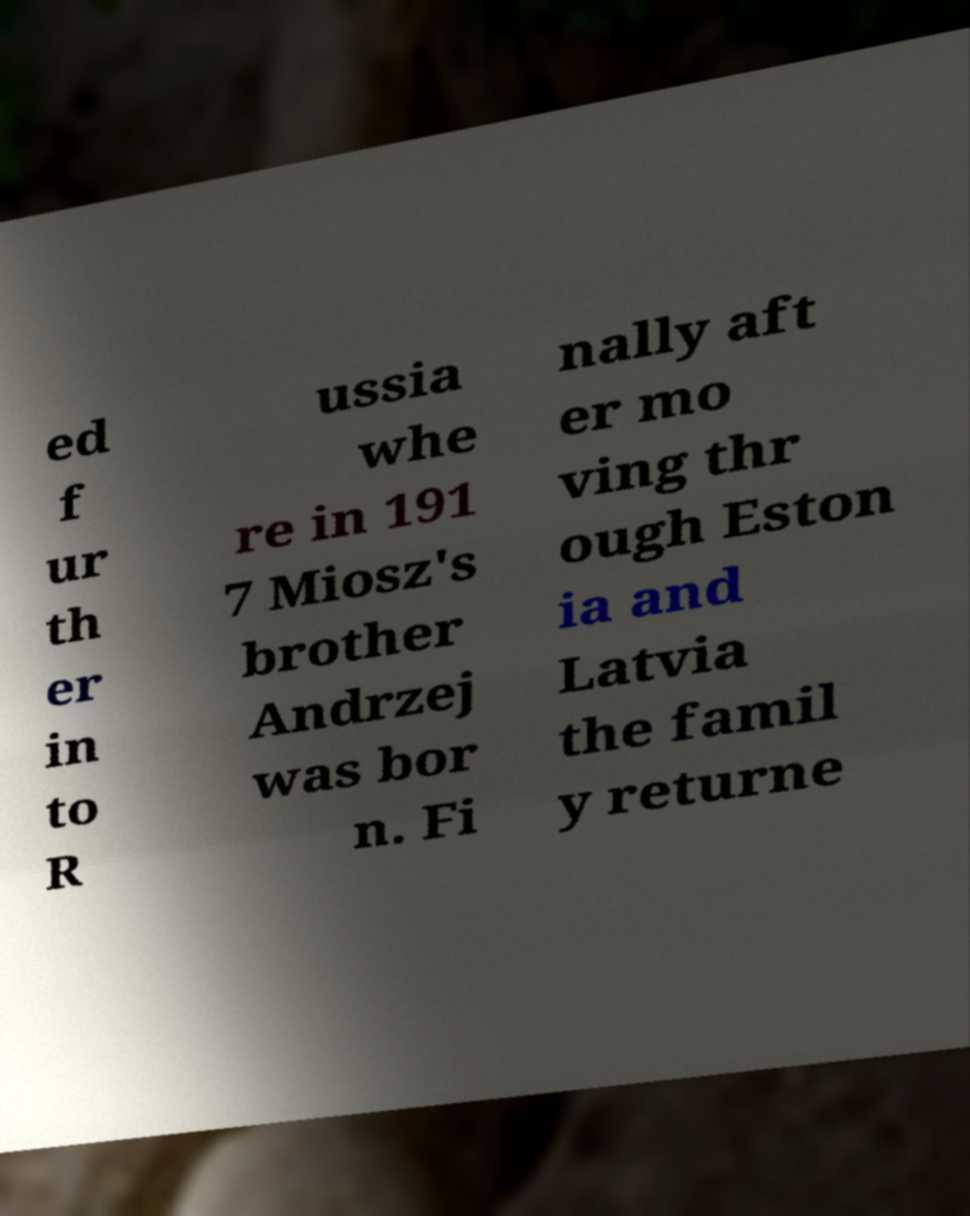There's text embedded in this image that I need extracted. Can you transcribe it verbatim? ed f ur th er in to R ussia whe re in 191 7 Miosz's brother Andrzej was bor n. Fi nally aft er mo ving thr ough Eston ia and Latvia the famil y returne 